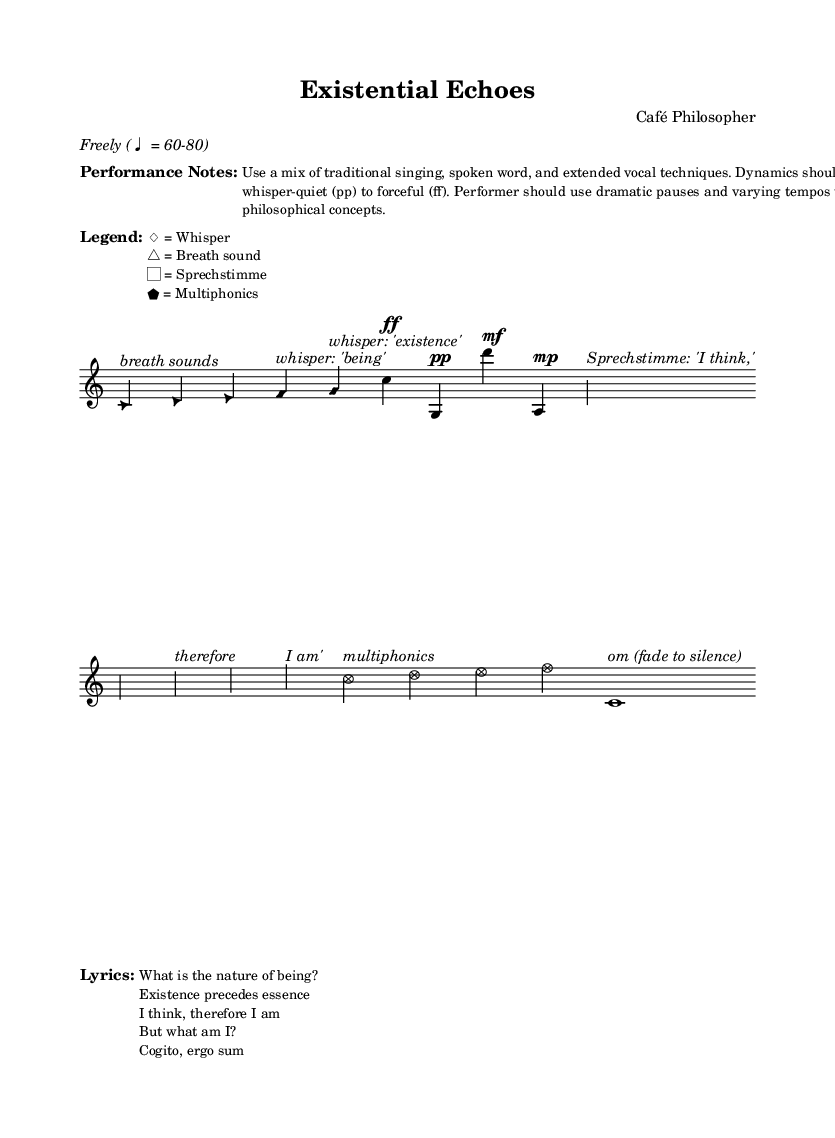What is the tempo marking for this piece? The tempo marking is "Freely (♩ = 60-80)," indicating that the performer should have a flexible interpretation within the specified beats per minute range.
Answer: Freely (♩ = 60-80) What is the dynamic marking for the first note in Section A? The first note in Section A is marked with a dynamic of "ff" (forte), indicating it should be played loudly.
Answer: ff What vocal technique is indicated for the note in the introduction with a diamond note head? The note with a diamond note head is marked for whispering "being," showing that a specific vocal technique (whisper) is being used here.
Answer: whisper Which philosophical concept is addressed in the lyrics "I think, therefore I am"? The lyrics directly reference Descartes' philosophical concept of existence and the act of thinking as proof of being.
Answer: existence How many sections are there in this composition? The composition is structured into four distinct sections: Introduction, Section A, Section B, Section C, and a Coda. Counting these reveals a total of five parts, including the Introduction and Coda.
Answer: Five What is the first auditory effect used in the introduction? The introduction begins with "breath sounds," as indicated by the notation and description provided.
Answer: breath sounds 